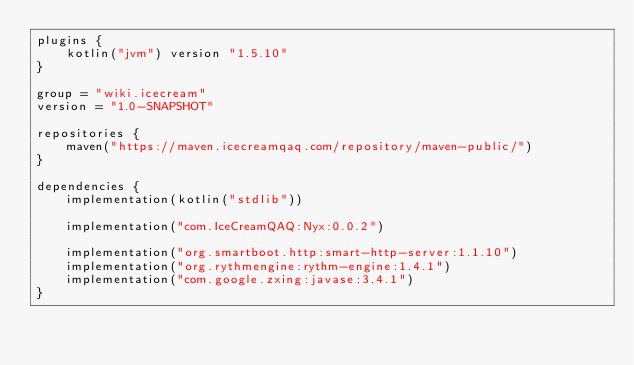Convert code to text. <code><loc_0><loc_0><loc_500><loc_500><_Kotlin_>plugins {
    kotlin("jvm") version "1.5.10"
}

group = "wiki.icecream"
version = "1.0-SNAPSHOT"

repositories {
    maven("https://maven.icecreamqaq.com/repository/maven-public/")
}

dependencies {
    implementation(kotlin("stdlib"))

    implementation("com.IceCreamQAQ:Nyx:0.0.2")

    implementation("org.smartboot.http:smart-http-server:1.1.10")
    implementation("org.rythmengine:rythm-engine:1.4.1")
    implementation("com.google.zxing:javase:3.4.1")
}</code> 